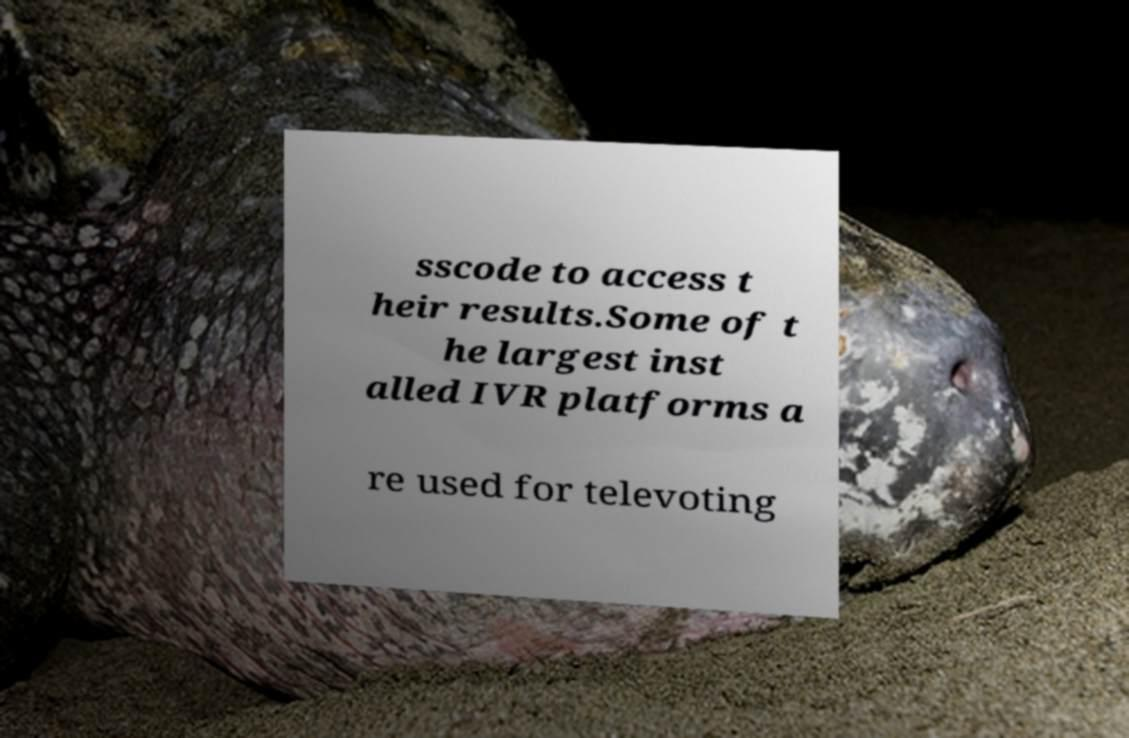Please identify and transcribe the text found in this image. sscode to access t heir results.Some of t he largest inst alled IVR platforms a re used for televoting 